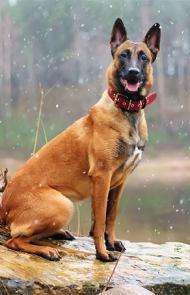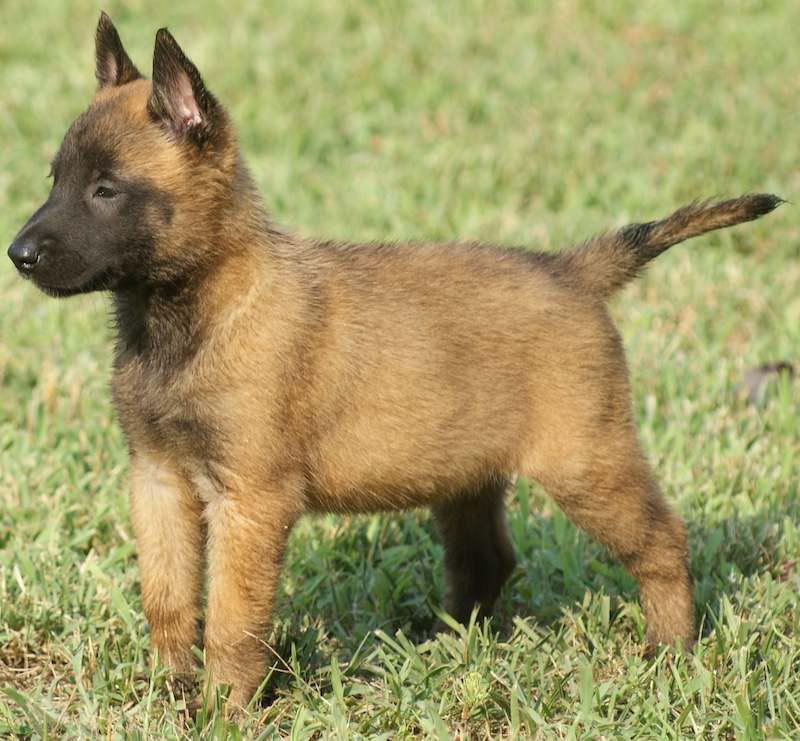The first image is the image on the left, the second image is the image on the right. For the images displayed, is the sentence "The dog in the image on the right is wearing a collar." factually correct? Answer yes or no. No. The first image is the image on the left, the second image is the image on the right. Examine the images to the left and right. Is the description "One image contains a puppy standing on all fours, and the other contains a dog with upright ears wearing a red collar." accurate? Answer yes or no. Yes. 